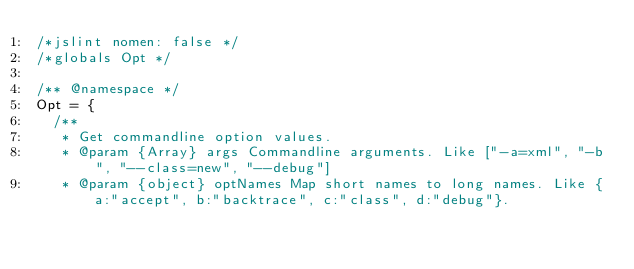<code> <loc_0><loc_0><loc_500><loc_500><_JavaScript_>/*jslint nomen: false */
/*globals Opt */

/** @namespace */
Opt = {
	/**
	 * Get commandline option values.
	 * @param {Array} args Commandline arguments. Like ["-a=xml", "-b", "--class=new", "--debug"]
	 * @param {object} optNames Map short names to long names. Like {a:"accept", b:"backtrace", c:"class", d:"debug"}.</code> 